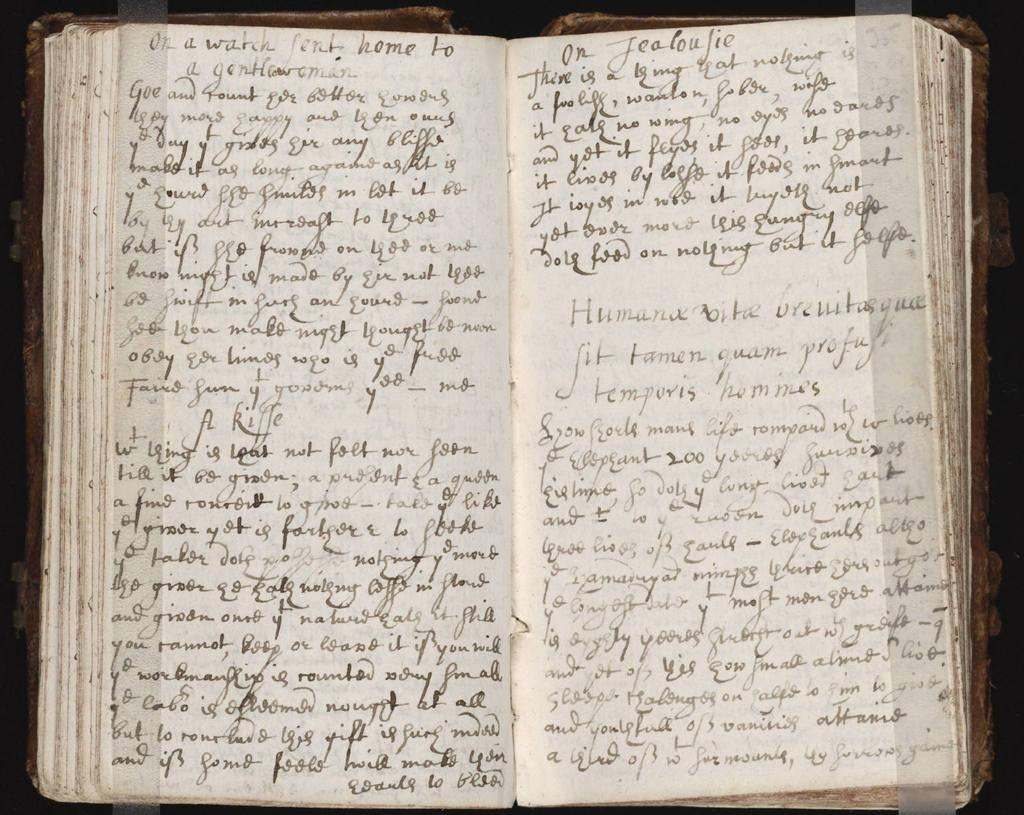<image>
Give a short and clear explanation of the subsequent image. A book of handwritten words including "On a watch" as the first three words. 